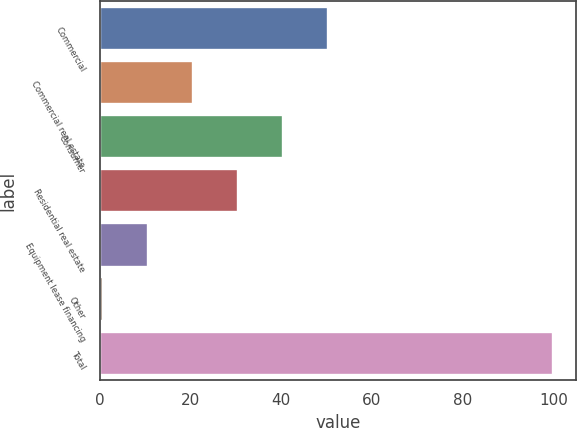Convert chart. <chart><loc_0><loc_0><loc_500><loc_500><bar_chart><fcel>Commercial<fcel>Commercial real estate<fcel>Consumer<fcel>Residential real estate<fcel>Equipment lease financing<fcel>Other<fcel>Total<nl><fcel>50.35<fcel>20.56<fcel>40.42<fcel>30.49<fcel>10.63<fcel>0.7<fcel>100<nl></chart> 